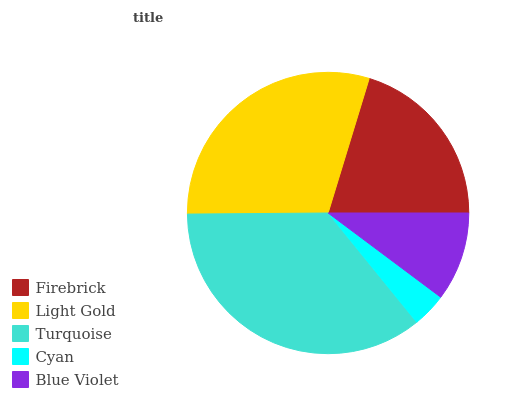Is Cyan the minimum?
Answer yes or no. Yes. Is Turquoise the maximum?
Answer yes or no. Yes. Is Light Gold the minimum?
Answer yes or no. No. Is Light Gold the maximum?
Answer yes or no. No. Is Light Gold greater than Firebrick?
Answer yes or no. Yes. Is Firebrick less than Light Gold?
Answer yes or no. Yes. Is Firebrick greater than Light Gold?
Answer yes or no. No. Is Light Gold less than Firebrick?
Answer yes or no. No. Is Firebrick the high median?
Answer yes or no. Yes. Is Firebrick the low median?
Answer yes or no. Yes. Is Light Gold the high median?
Answer yes or no. No. Is Cyan the low median?
Answer yes or no. No. 